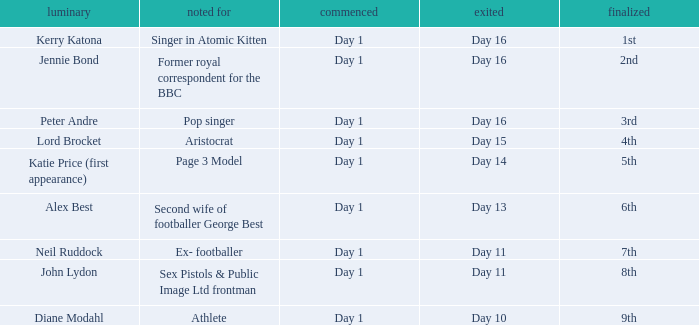Name the finished for kerry katona 1.0. 